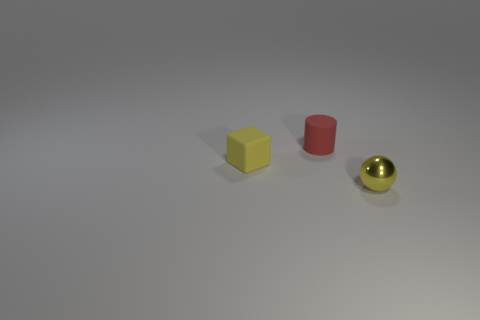Add 1 small matte objects. How many objects exist? 4 Subtract all cylinders. How many objects are left? 2 Subtract all cylinders. Subtract all yellow shiny objects. How many objects are left? 1 Add 3 small metal spheres. How many small metal spheres are left? 4 Add 2 tiny purple cylinders. How many tiny purple cylinders exist? 2 Subtract 0 blue cylinders. How many objects are left? 3 